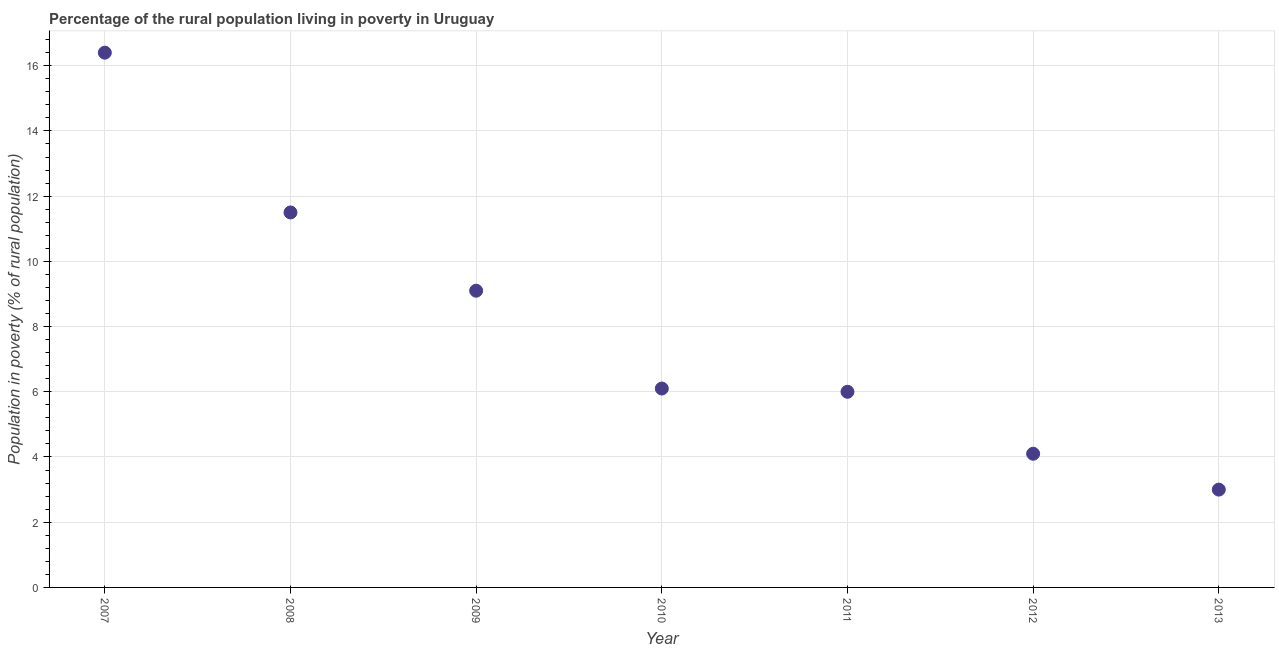What is the percentage of rural population living below poverty line in 2008?
Ensure brevity in your answer.  11.5. Across all years, what is the maximum percentage of rural population living below poverty line?
Offer a very short reply. 16.4. Across all years, what is the minimum percentage of rural population living below poverty line?
Offer a very short reply. 3. What is the sum of the percentage of rural population living below poverty line?
Provide a succinct answer. 56.2. What is the difference between the percentage of rural population living below poverty line in 2007 and 2010?
Make the answer very short. 10.3. What is the average percentage of rural population living below poverty line per year?
Your answer should be very brief. 8.03. What is the median percentage of rural population living below poverty line?
Your answer should be compact. 6.1. What is the ratio of the percentage of rural population living below poverty line in 2009 to that in 2011?
Make the answer very short. 1.52. Is the difference between the percentage of rural population living below poverty line in 2009 and 2011 greater than the difference between any two years?
Keep it short and to the point. No. What is the difference between the highest and the second highest percentage of rural population living below poverty line?
Offer a terse response. 4.9. What is the difference between the highest and the lowest percentage of rural population living below poverty line?
Your answer should be compact. 13.4. How many dotlines are there?
Give a very brief answer. 1. Does the graph contain any zero values?
Provide a succinct answer. No. Does the graph contain grids?
Provide a succinct answer. Yes. What is the title of the graph?
Your answer should be compact. Percentage of the rural population living in poverty in Uruguay. What is the label or title of the X-axis?
Make the answer very short. Year. What is the label or title of the Y-axis?
Your response must be concise. Population in poverty (% of rural population). What is the Population in poverty (% of rural population) in 2007?
Offer a very short reply. 16.4. What is the Population in poverty (% of rural population) in 2008?
Keep it short and to the point. 11.5. What is the Population in poverty (% of rural population) in 2010?
Provide a short and direct response. 6.1. What is the Population in poverty (% of rural population) in 2011?
Give a very brief answer. 6. What is the difference between the Population in poverty (% of rural population) in 2007 and 2008?
Offer a terse response. 4.9. What is the difference between the Population in poverty (% of rural population) in 2007 and 2009?
Make the answer very short. 7.3. What is the difference between the Population in poverty (% of rural population) in 2008 and 2010?
Keep it short and to the point. 5.4. What is the difference between the Population in poverty (% of rural population) in 2008 and 2013?
Offer a terse response. 8.5. What is the difference between the Population in poverty (% of rural population) in 2009 and 2010?
Offer a very short reply. 3. What is the difference between the Population in poverty (% of rural population) in 2009 and 2013?
Ensure brevity in your answer.  6.1. What is the difference between the Population in poverty (% of rural population) in 2010 and 2011?
Offer a terse response. 0.1. What is the difference between the Population in poverty (% of rural population) in 2010 and 2013?
Give a very brief answer. 3.1. What is the difference between the Population in poverty (% of rural population) in 2011 and 2013?
Offer a very short reply. 3. What is the ratio of the Population in poverty (% of rural population) in 2007 to that in 2008?
Your answer should be very brief. 1.43. What is the ratio of the Population in poverty (% of rural population) in 2007 to that in 2009?
Your answer should be compact. 1.8. What is the ratio of the Population in poverty (% of rural population) in 2007 to that in 2010?
Offer a terse response. 2.69. What is the ratio of the Population in poverty (% of rural population) in 2007 to that in 2011?
Offer a very short reply. 2.73. What is the ratio of the Population in poverty (% of rural population) in 2007 to that in 2012?
Give a very brief answer. 4. What is the ratio of the Population in poverty (% of rural population) in 2007 to that in 2013?
Make the answer very short. 5.47. What is the ratio of the Population in poverty (% of rural population) in 2008 to that in 2009?
Give a very brief answer. 1.26. What is the ratio of the Population in poverty (% of rural population) in 2008 to that in 2010?
Your response must be concise. 1.89. What is the ratio of the Population in poverty (% of rural population) in 2008 to that in 2011?
Make the answer very short. 1.92. What is the ratio of the Population in poverty (% of rural population) in 2008 to that in 2012?
Your answer should be very brief. 2.81. What is the ratio of the Population in poverty (% of rural population) in 2008 to that in 2013?
Make the answer very short. 3.83. What is the ratio of the Population in poverty (% of rural population) in 2009 to that in 2010?
Offer a terse response. 1.49. What is the ratio of the Population in poverty (% of rural population) in 2009 to that in 2011?
Keep it short and to the point. 1.52. What is the ratio of the Population in poverty (% of rural population) in 2009 to that in 2012?
Ensure brevity in your answer.  2.22. What is the ratio of the Population in poverty (% of rural population) in 2009 to that in 2013?
Your answer should be compact. 3.03. What is the ratio of the Population in poverty (% of rural population) in 2010 to that in 2012?
Provide a short and direct response. 1.49. What is the ratio of the Population in poverty (% of rural population) in 2010 to that in 2013?
Provide a succinct answer. 2.03. What is the ratio of the Population in poverty (% of rural population) in 2011 to that in 2012?
Keep it short and to the point. 1.46. What is the ratio of the Population in poverty (% of rural population) in 2012 to that in 2013?
Provide a succinct answer. 1.37. 